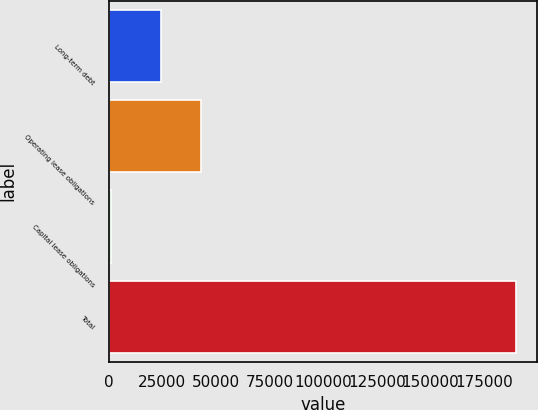Convert chart. <chart><loc_0><loc_0><loc_500><loc_500><bar_chart><fcel>Long-term debt<fcel>Operating lease obligations<fcel>Capital lease obligations<fcel>Total<nl><fcel>24362<fcel>43277<fcel>943<fcel>190093<nl></chart> 